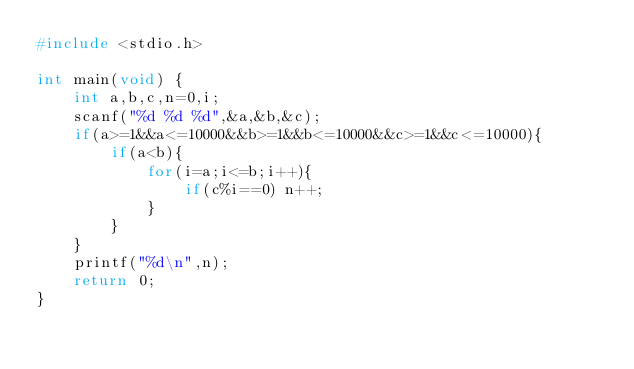<code> <loc_0><loc_0><loc_500><loc_500><_C_>#include <stdio.h>

int main(void) {
	int a,b,c,n=0,i;
	scanf("%d %d %d",&a,&b,&c);
	if(a>=1&&a<=10000&&b>=1&&b<=10000&&c>=1&&c<=10000){
		if(a<b){
			for(i=a;i<=b;i++){
				if(c%i==0) n++;
			}
		}
	}
	printf("%d\n",n);
	return 0;
}

</code> 